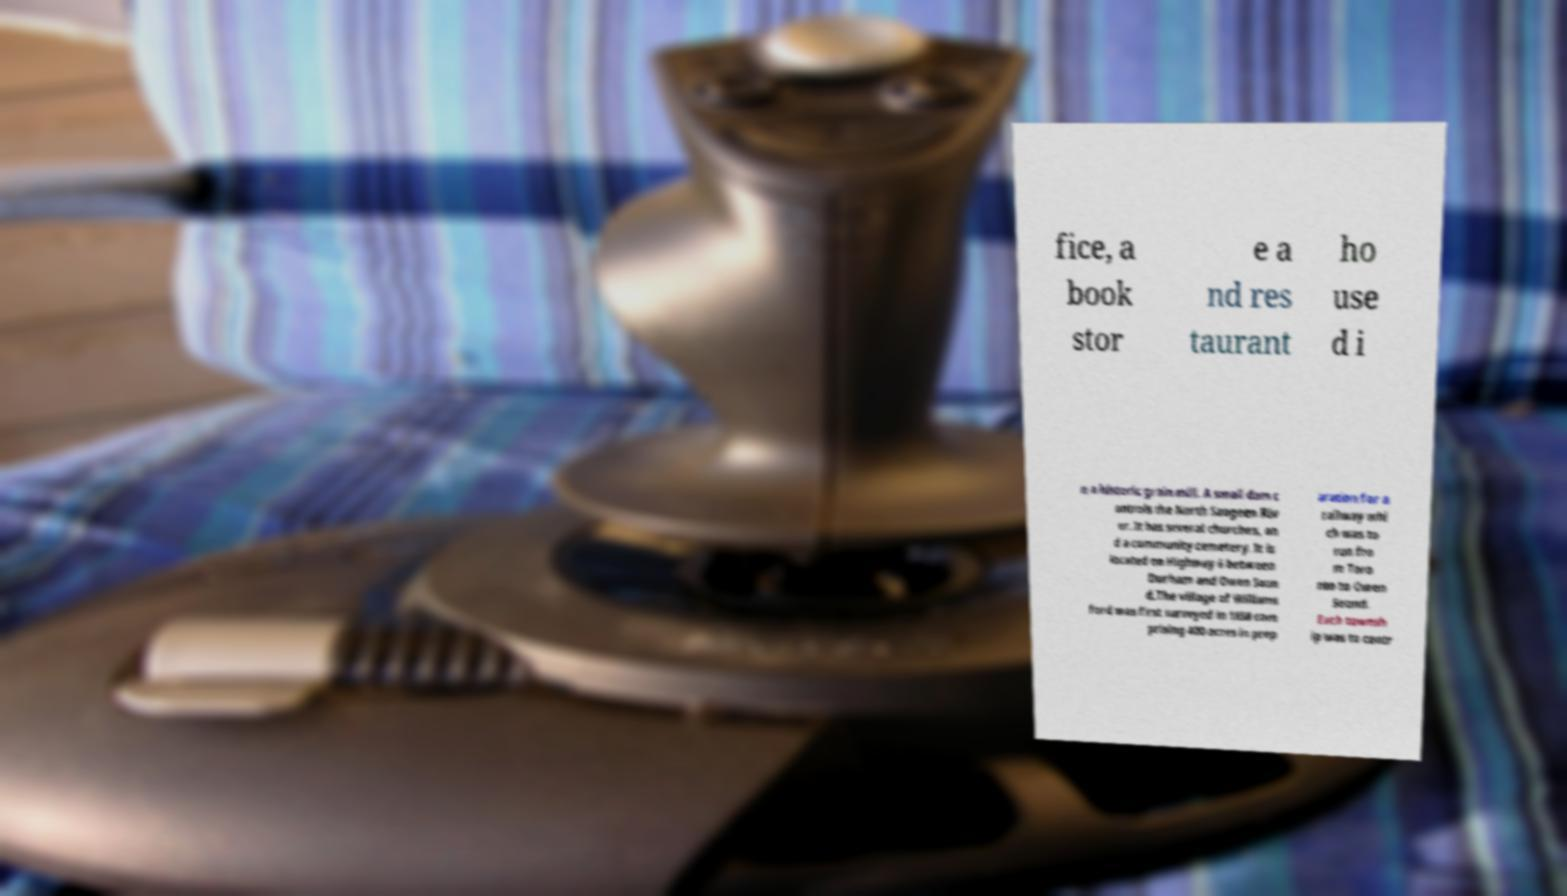Can you read and provide the text displayed in the image?This photo seems to have some interesting text. Can you extract and type it out for me? fice, a book stor e a nd res taurant ho use d i n a historic grain mill. A small dam c ontrols the North Saugeen Riv er. It has several churches, an d a community cemetery. It is located on Highway 6 between Durham and Owen Soun d.The village of Williams ford was first surveyed in 1858 com prising 400 acres in prep aration for a railway whi ch was to run fro m Toro nto to Owen Sound. Each townsh ip was to contr 